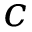<formula> <loc_0><loc_0><loc_500><loc_500>c</formula> 